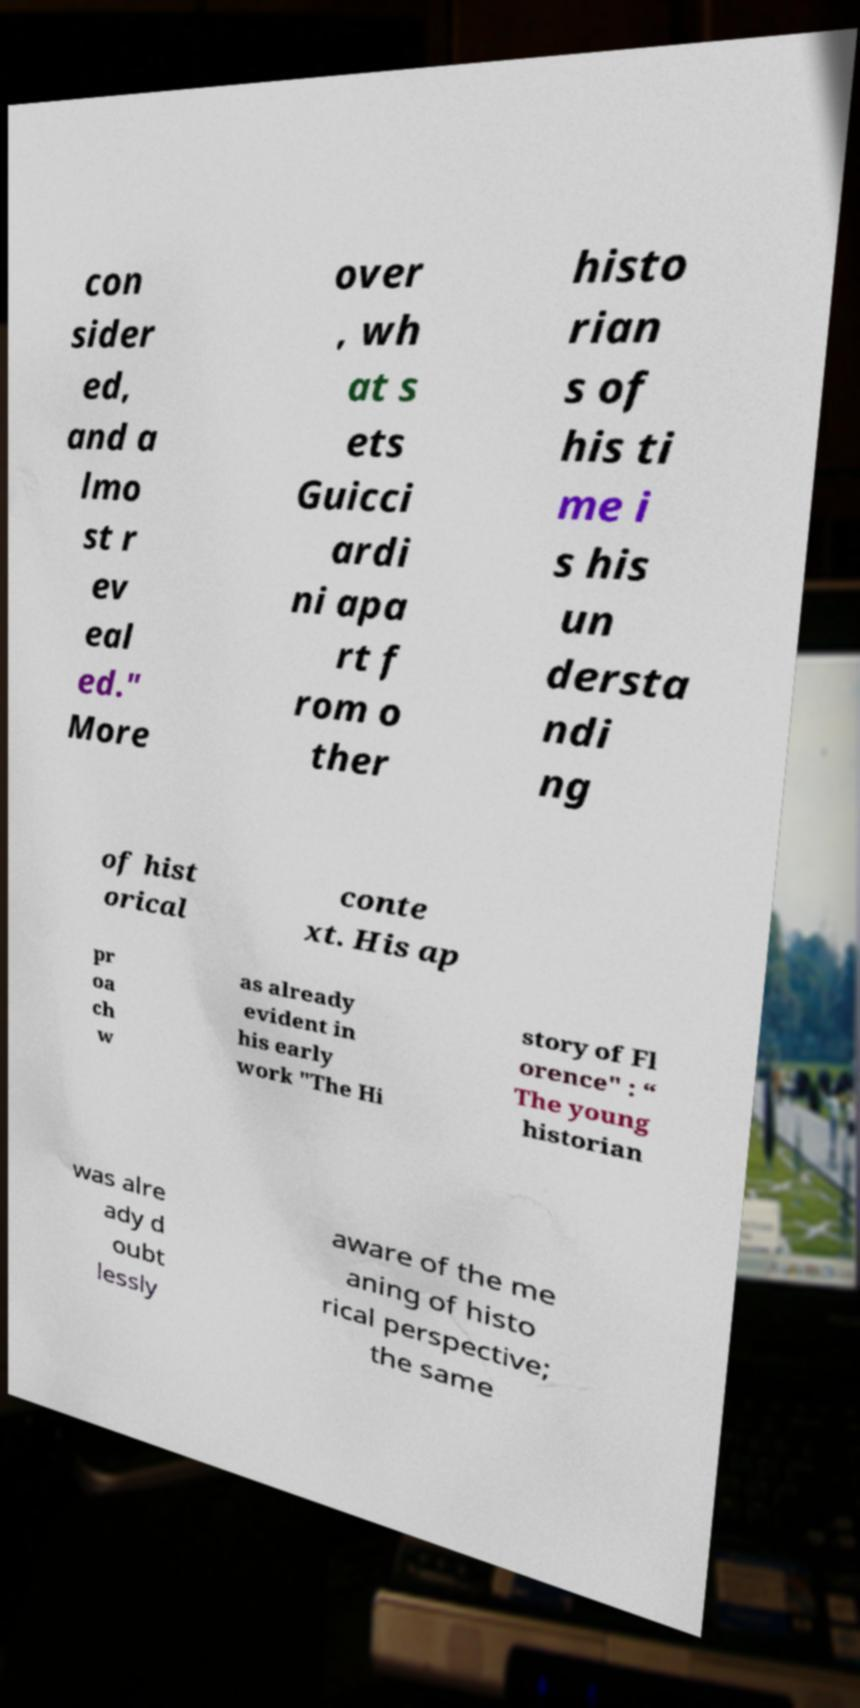I need the written content from this picture converted into text. Can you do that? con sider ed, and a lmo st r ev eal ed." More over , wh at s ets Guicci ardi ni apa rt f rom o ther histo rian s of his ti me i s his un dersta ndi ng of hist orical conte xt. His ap pr oa ch w as already evident in his early work "The Hi story of Fl orence" : “ The young historian was alre ady d oubt lessly aware of the me aning of histo rical perspective; the same 